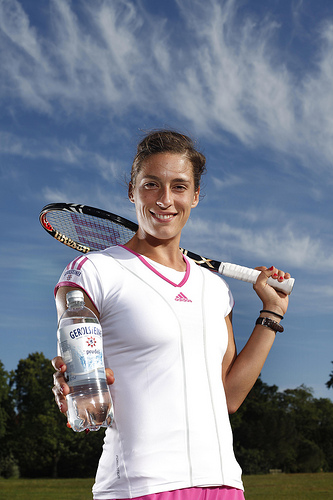How many people are in the photo? There is only one person visible in the photo, standing outdoors with a clear sky in the background. She is smiling and holding a bottle of water in one hand and a tennis racket over her shoulder with the other hand, suggesting she might be a tennis player or engaged in some form of sporting activity. 